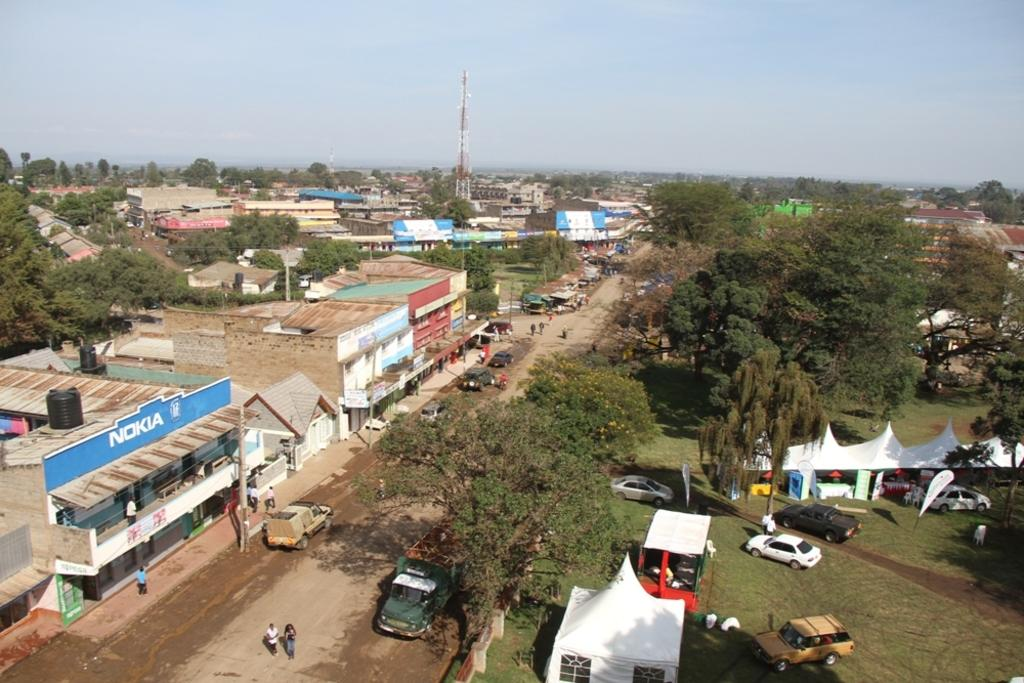What type of natural elements are present in the image? There are trees in the image. What type of man-made structures can be seen in the image? There are buildings and a tower in the image. What is visible in the background of the image? The sky is visible in the background of the image. What type of milk is being used to act as a paint in the image? There is no milk or painting activity present in the image. What is the mind of the tree doing in the image? Trees do not have minds, and there is no indication of any mind-related activity in the image. 